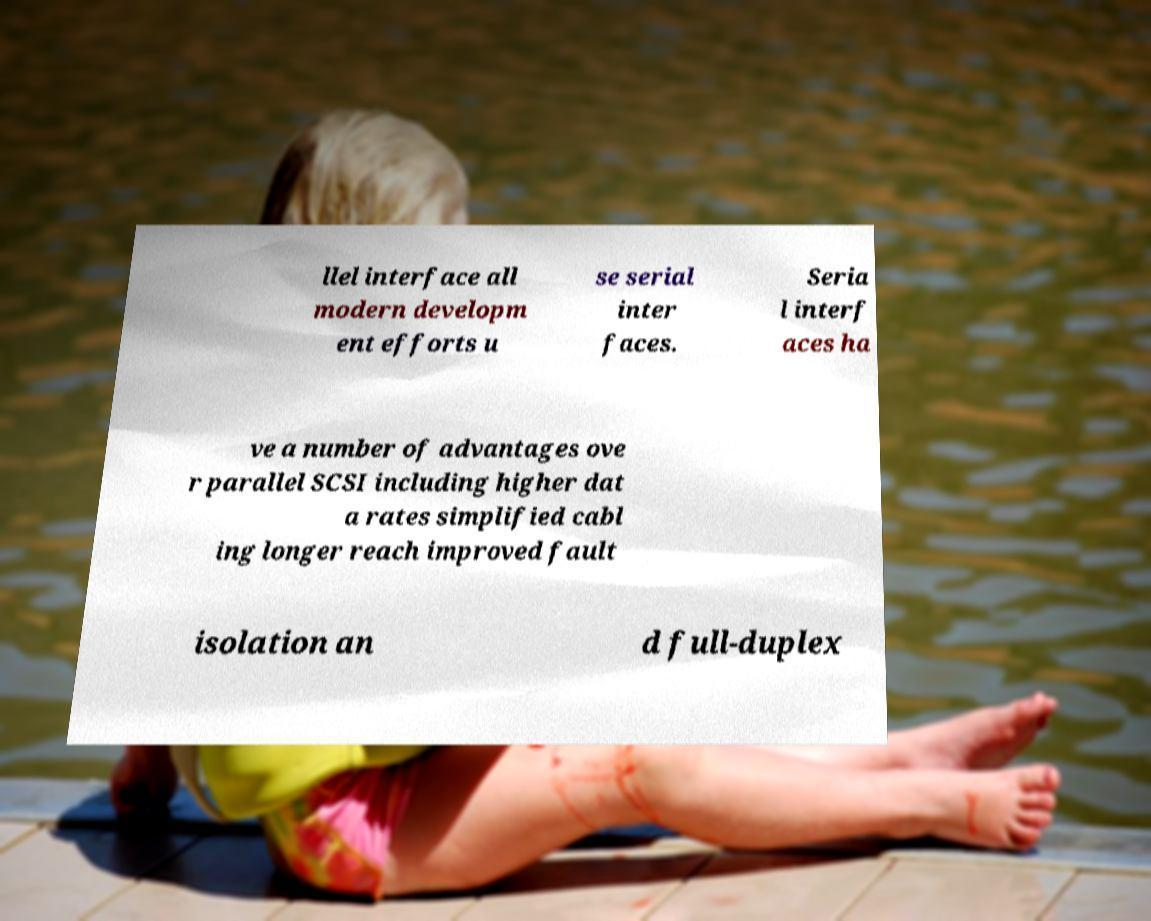What messages or text are displayed in this image? I need them in a readable, typed format. llel interface all modern developm ent efforts u se serial inter faces. Seria l interf aces ha ve a number of advantages ove r parallel SCSI including higher dat a rates simplified cabl ing longer reach improved fault isolation an d full-duplex 